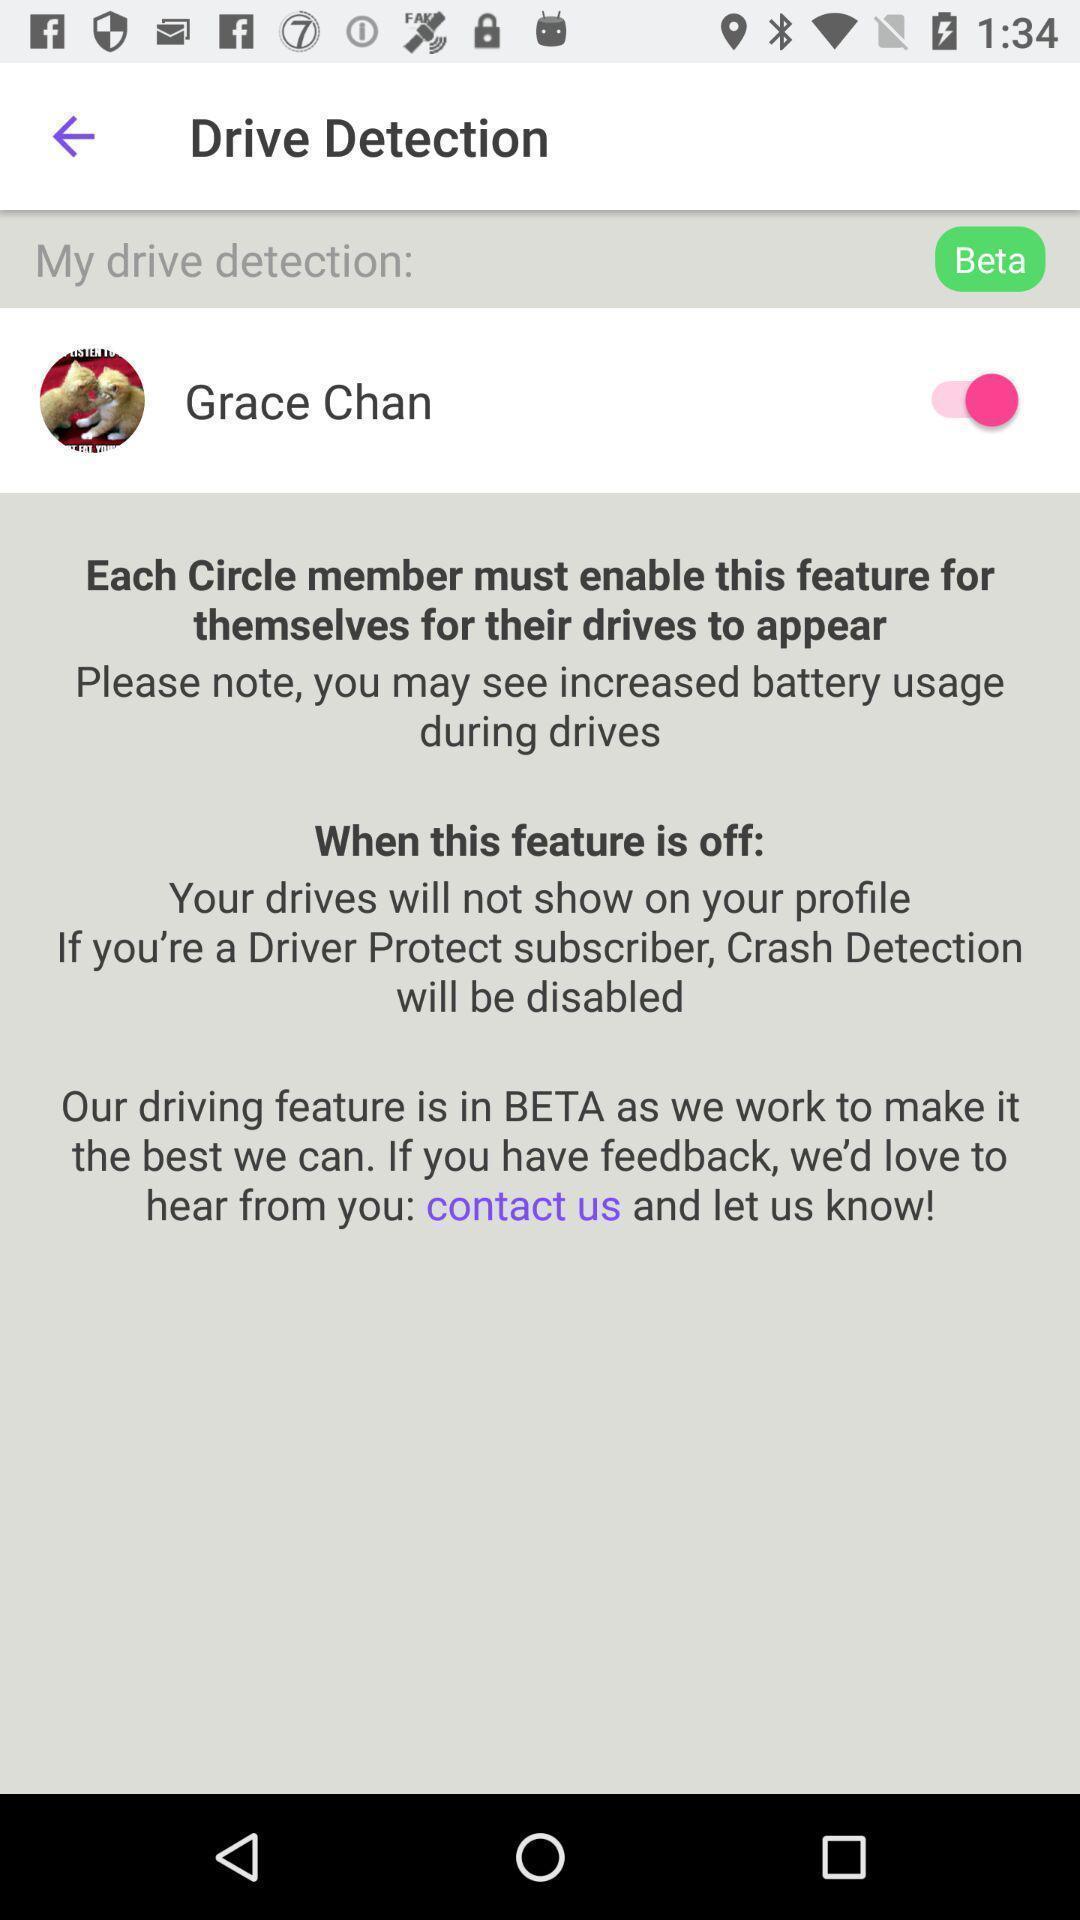What is the overall content of this screenshot? Page displaying the information of the app. 